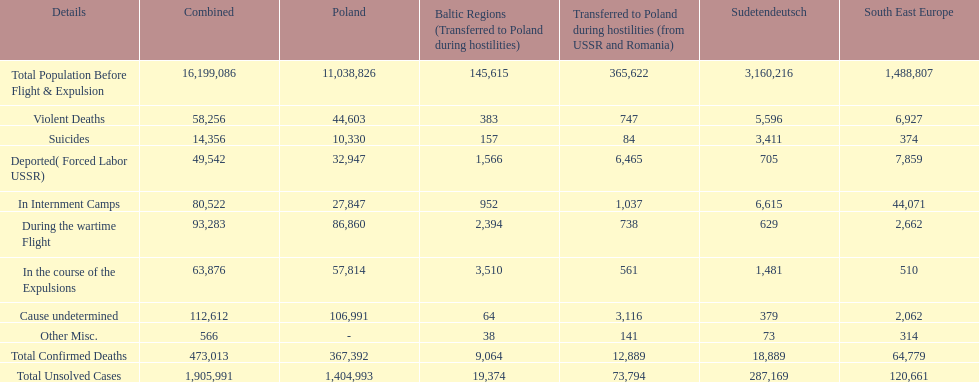Did any location have no violent deaths? No. 